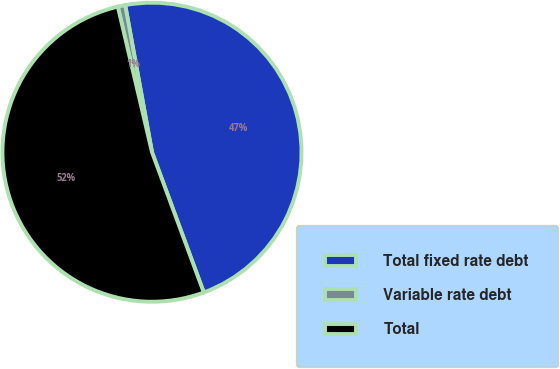<chart> <loc_0><loc_0><loc_500><loc_500><pie_chart><fcel>Total fixed rate debt<fcel>Variable rate debt<fcel>Total<nl><fcel>47.24%<fcel>0.8%<fcel>51.96%<nl></chart> 